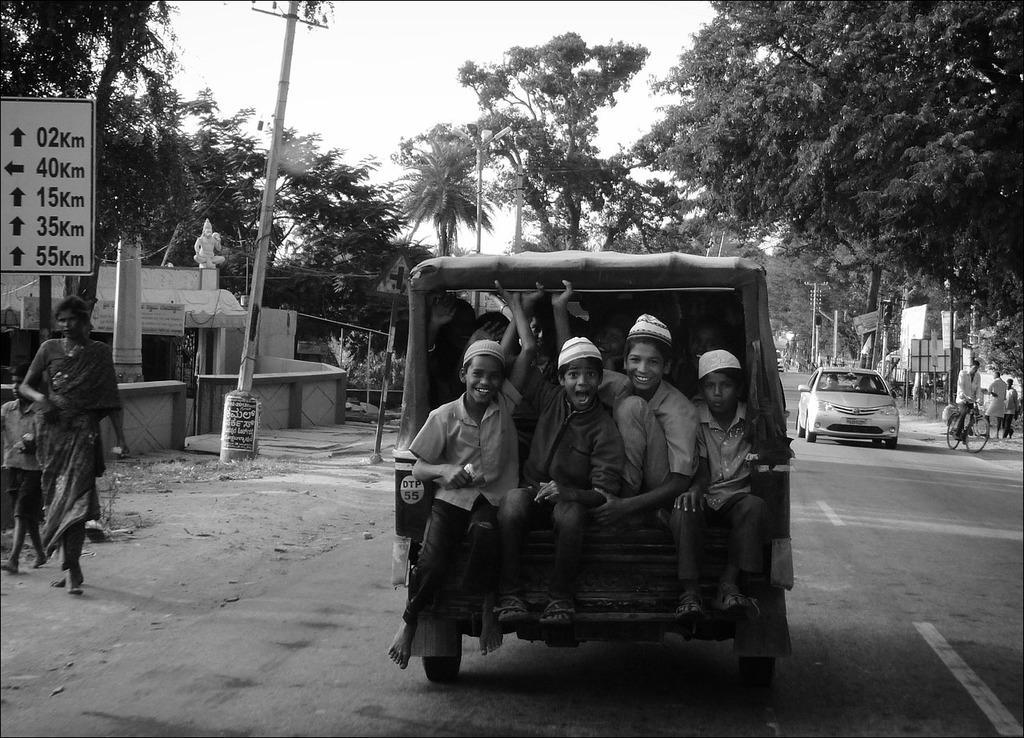Describe this image in one or two sentences. In the picture I can see vehicles on the road. I can also see people among them some are sitting in a vehicle and some on the ground. In the background I can see trees, the sky, buildings, poles which has wires attached to them, a board which has something written on it, buildings, bicycle on road and some other objects. This picture is black and white in color. 